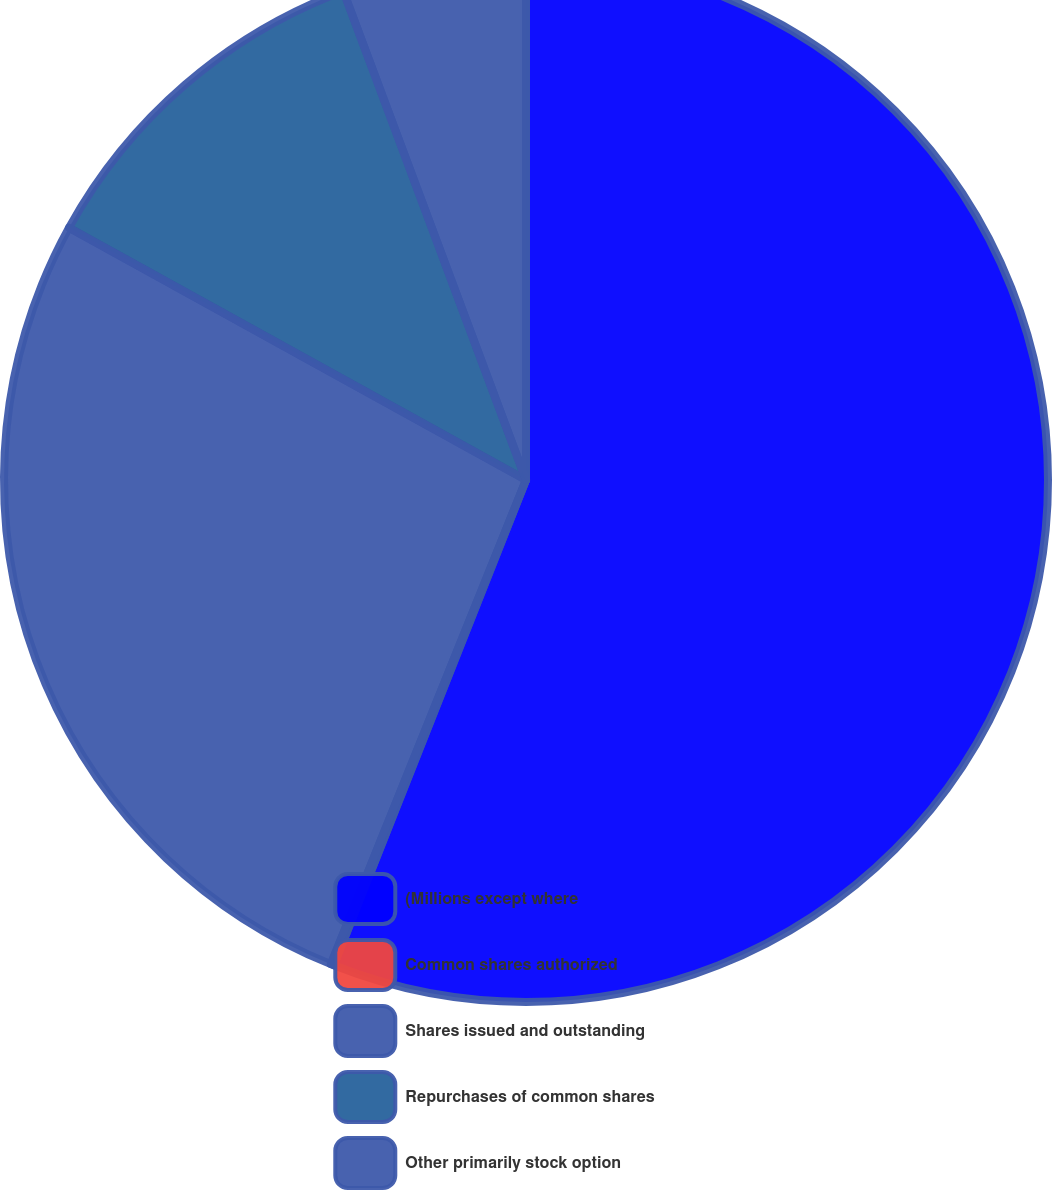Convert chart. <chart><loc_0><loc_0><loc_500><loc_500><pie_chart><fcel>(Millions except where<fcel>Common shares authorized<fcel>Shares issued and outstanding<fcel>Repurchases of common shares<fcel>Other primarily stock option<nl><fcel>56.0%<fcel>0.1%<fcel>26.93%<fcel>11.28%<fcel>5.69%<nl></chart> 